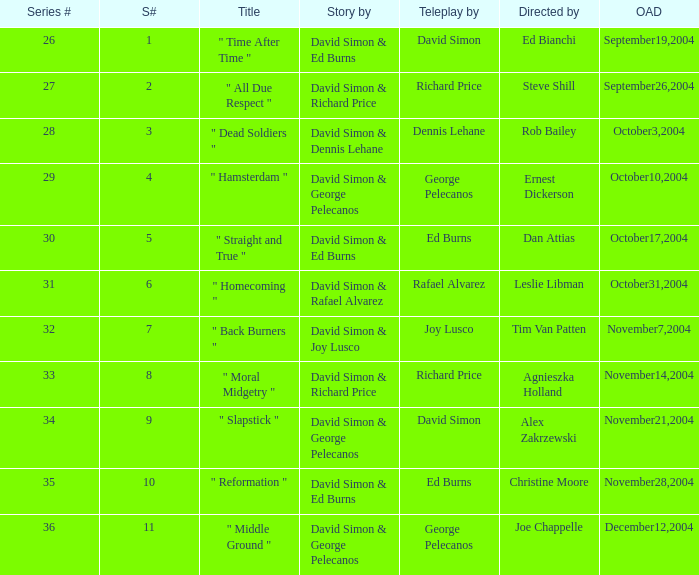What is the total number of values for "Teleplay by" category for series # 35? 1.0. 